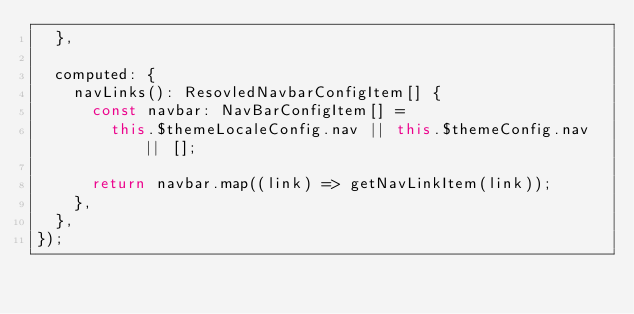<code> <loc_0><loc_0><loc_500><loc_500><_TypeScript_>  },

  computed: {
    navLinks(): ResovledNavbarConfigItem[] {
      const navbar: NavBarConfigItem[] =
        this.$themeLocaleConfig.nav || this.$themeConfig.nav || [];

      return navbar.map((link) => getNavLinkItem(link));
    },
  },
});
</code> 